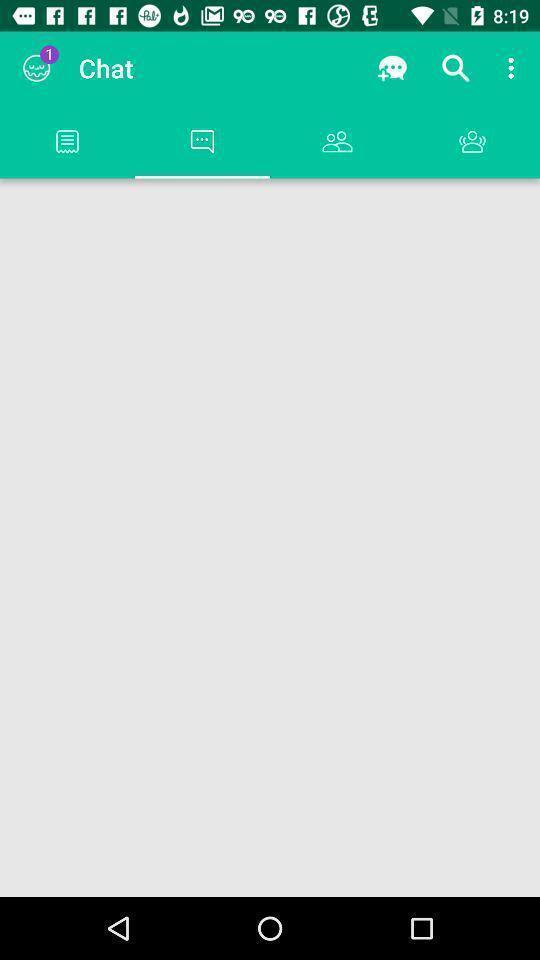Summarize the main components in this picture. Screen page showing multiple options. 